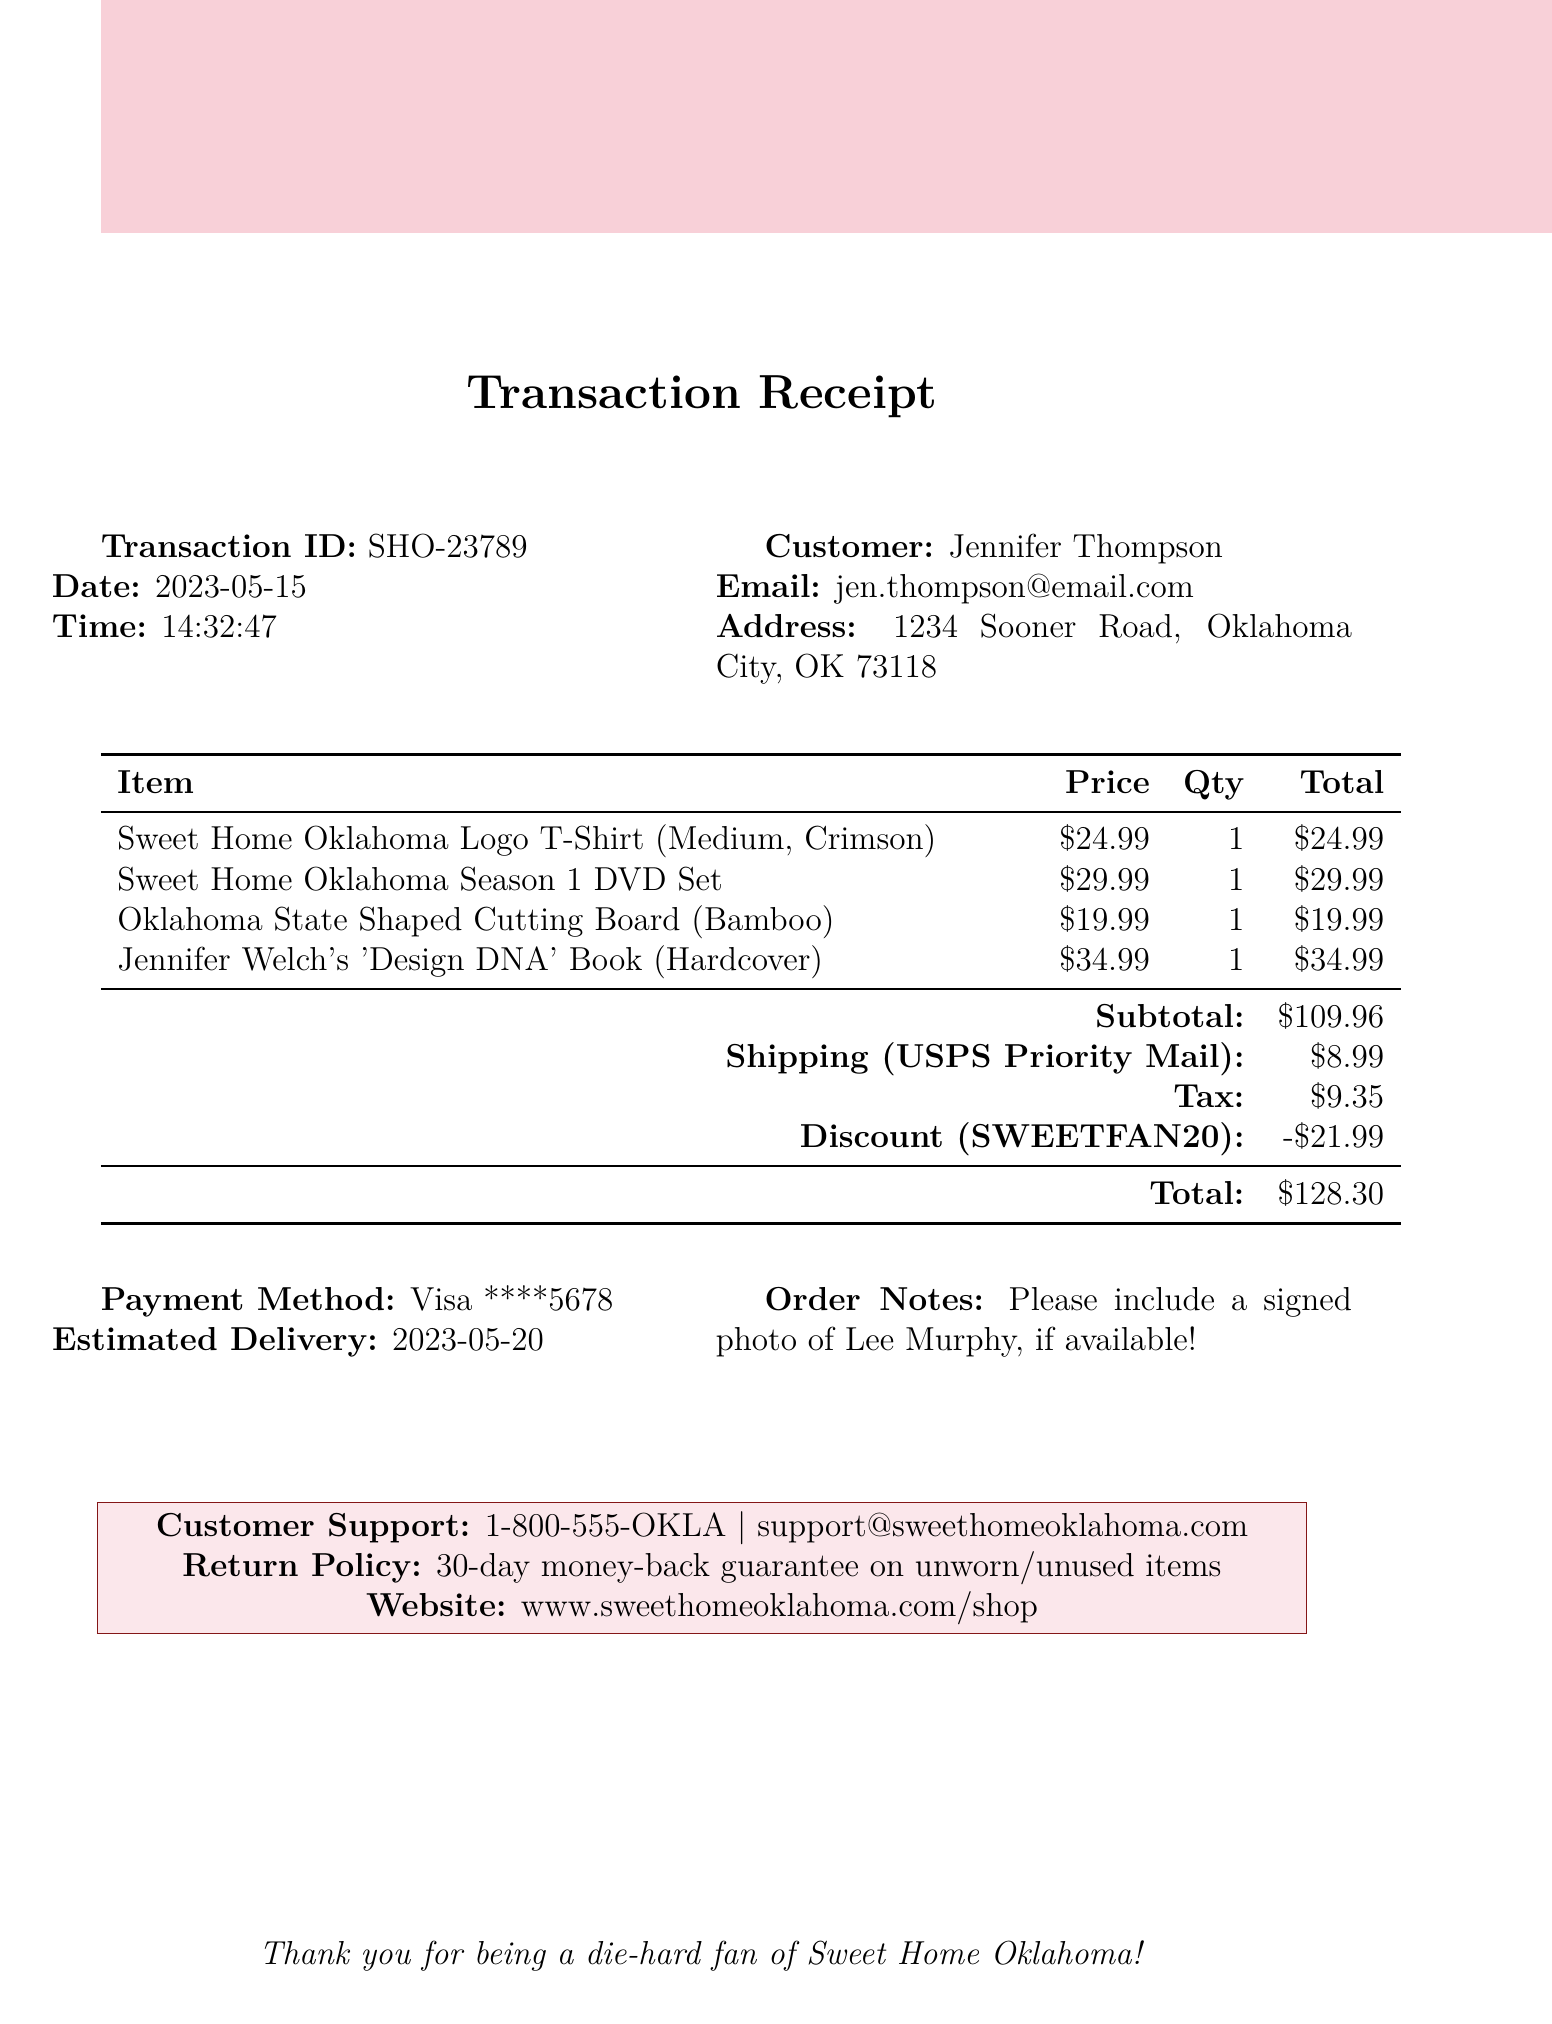What is the transaction ID? The transaction ID is a unique identifier provided in the document, which is SHO-23789.
Answer: SHO-23789 What is the date of the transaction? The date of the transaction is clearly mentioned in the document as the day it occurred.
Answer: 2023-05-15 What is the total amount charged? The total amount is the final sum including all items, tax, shipping, and discounts.
Answer: 128.30 What discount was applied? The document specifies the discount amount applied due to the promo code used during the transaction.
Answer: 21.99 What is the estimated delivery date? The estimated delivery date is provided in the document as when the customer can expect their items.
Answer: 2023-05-20 How many items are included in the bundle? The total number of items is derived from the list given in the document.
Answer: 4 What method of shipping was used? The shipping method is explicitly stated in the document, describing how the items were sent.
Answer: USPS Priority Mail What payment method was used? The payment method includes details about the type and the last four digits for security.
Answer: Visa ****5678 What is the return policy for items? The return policy outlines the conditions under which items can be returned, as stated in the document.
Answer: 30-day money-back guarantee on unworn/unused items 